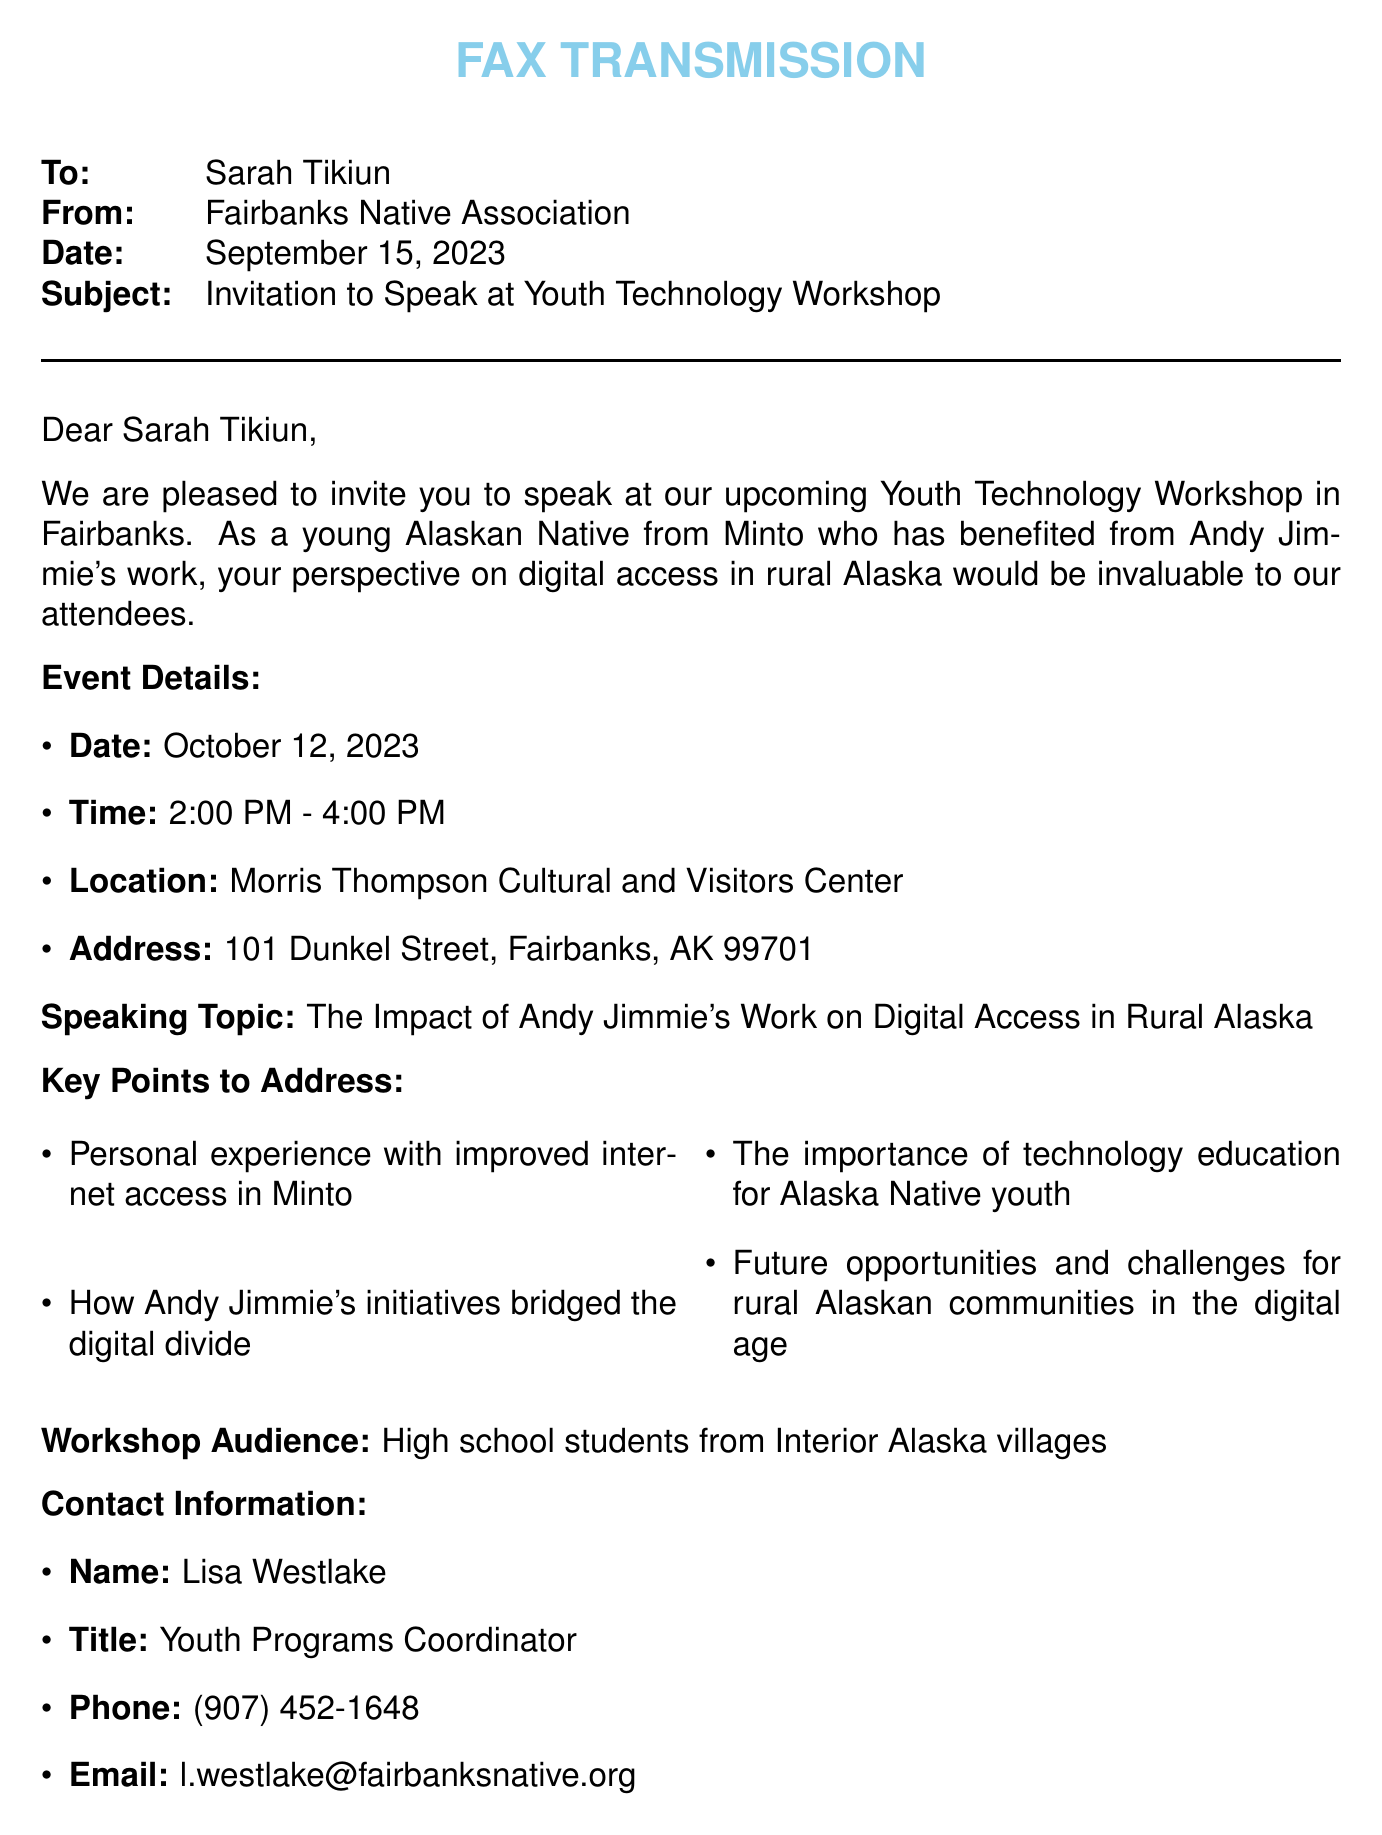What is the recipient's name? The recipient's name is clearly stated at the beginning of the fax.
Answer: Sarah Tikiun Who is sending the fax? The sender's name is provided alongside the organization they represent.
Answer: Fairbanks Native Association What is the date of the workshop? The date of the event is specified in the event details section.
Answer: October 12, 2023 What time does the workshop start? The starting time is mentioned directly in the event details.
Answer: 2:00 PM What topic will be discussed during the workshop? The speaking topic is outlined directly in the fax.
Answer: The Impact of Andy Jimmie's Work on Digital Access in Rural Alaska What is one key point to address? One of the key points is listed explicitly in the document.
Answer: Personal experience with improved internet access in Minto Who should be contacted for more information? The contact person's name is provided along with their title.
Answer: Lisa Westlake What is the workshop audience composed of? The audience is described clearly in the workshop section.
Answer: High school students from Interior Alaska villages By what date should attendance be confirmed? The confirmation deadline is noted at the end of the document.
Answer: September 30, 2023 